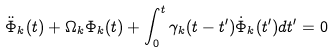<formula> <loc_0><loc_0><loc_500><loc_500>\ddot { \Phi } _ { k } ( t ) + \Omega _ { k } \Phi _ { k } ( t ) + \int _ { 0 } ^ { t } \gamma _ { k } ( t - t ^ { \prime } ) \dot { \Phi } _ { k } ( t ^ { \prime } ) d t ^ { \prime } = 0</formula> 